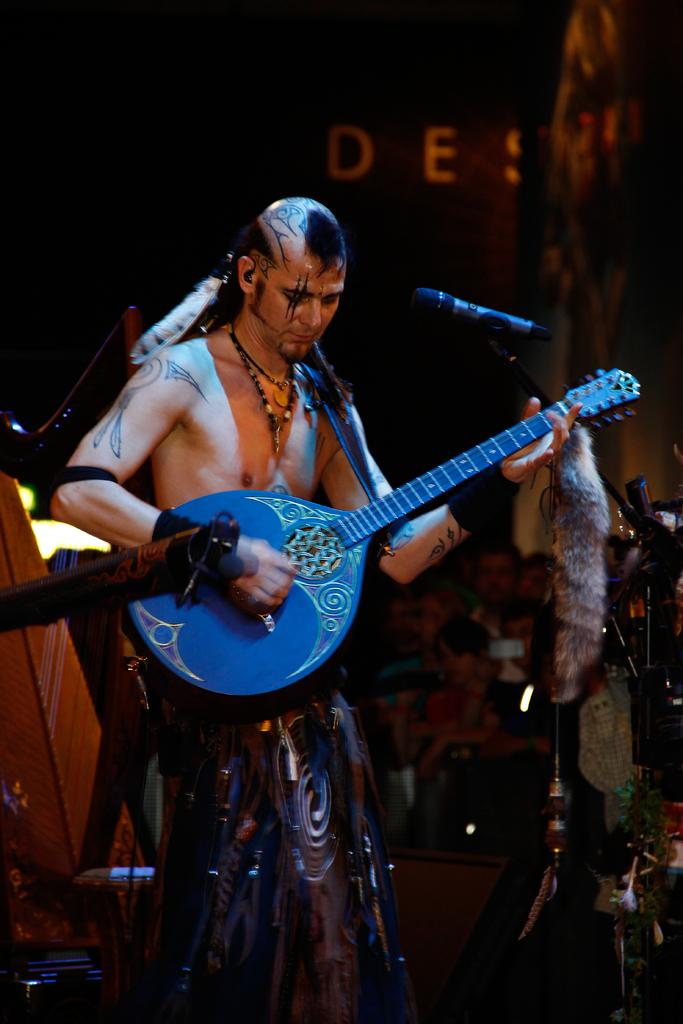What is the man in the image holding? The man is holding a guitar. What object is the man standing in front of? The man is standing in front of a microphone. Where is the man located in the image? The man is on a stage. What type of shoe is the man wearing in the image? There is no information about the man's shoes in the image. What kind of patch can be seen on the guitar in the image? There is no patch visible on the guitar in the image. 